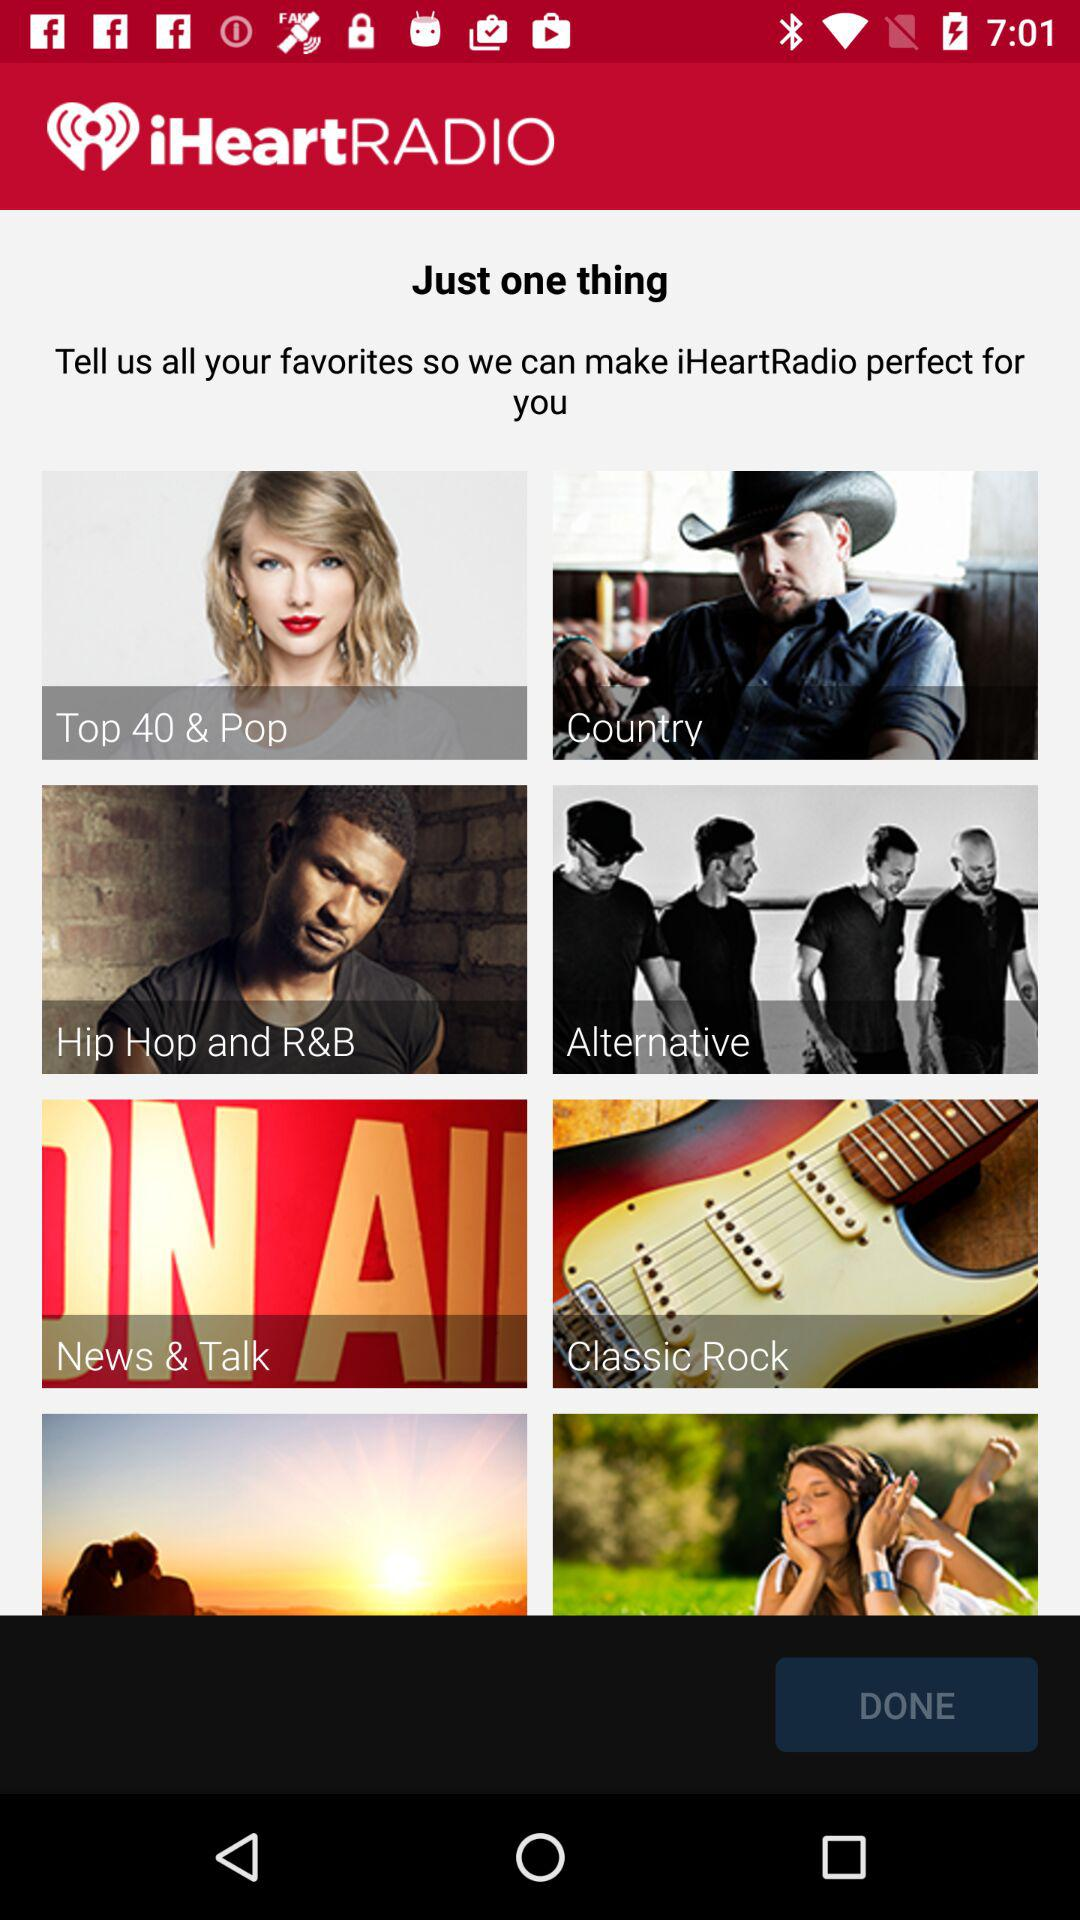What is the name of the application? The application name is "iHeartRADIO". 